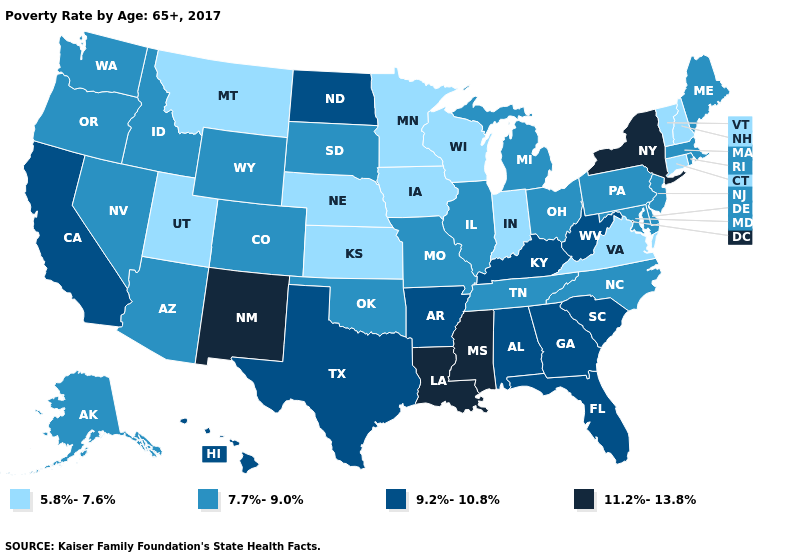Does Alabama have the lowest value in the South?
Answer briefly. No. Does Iowa have the highest value in the MidWest?
Write a very short answer. No. Does the map have missing data?
Concise answer only. No. What is the value of Utah?
Give a very brief answer. 5.8%-7.6%. Among the states that border Indiana , does Kentucky have the highest value?
Keep it brief. Yes. What is the highest value in states that border Nevada?
Concise answer only. 9.2%-10.8%. What is the value of Georgia?
Short answer required. 9.2%-10.8%. Is the legend a continuous bar?
Give a very brief answer. No. Does Georgia have the highest value in the USA?
Answer briefly. No. Among the states that border Minnesota , which have the lowest value?
Quick response, please. Iowa, Wisconsin. What is the highest value in states that border Michigan?
Keep it brief. 7.7%-9.0%. How many symbols are there in the legend?
Concise answer only. 4. Which states hav the highest value in the MidWest?
Write a very short answer. North Dakota. What is the value of Alaska?
Keep it brief. 7.7%-9.0%. Among the states that border Oklahoma , does New Mexico have the lowest value?
Write a very short answer. No. 